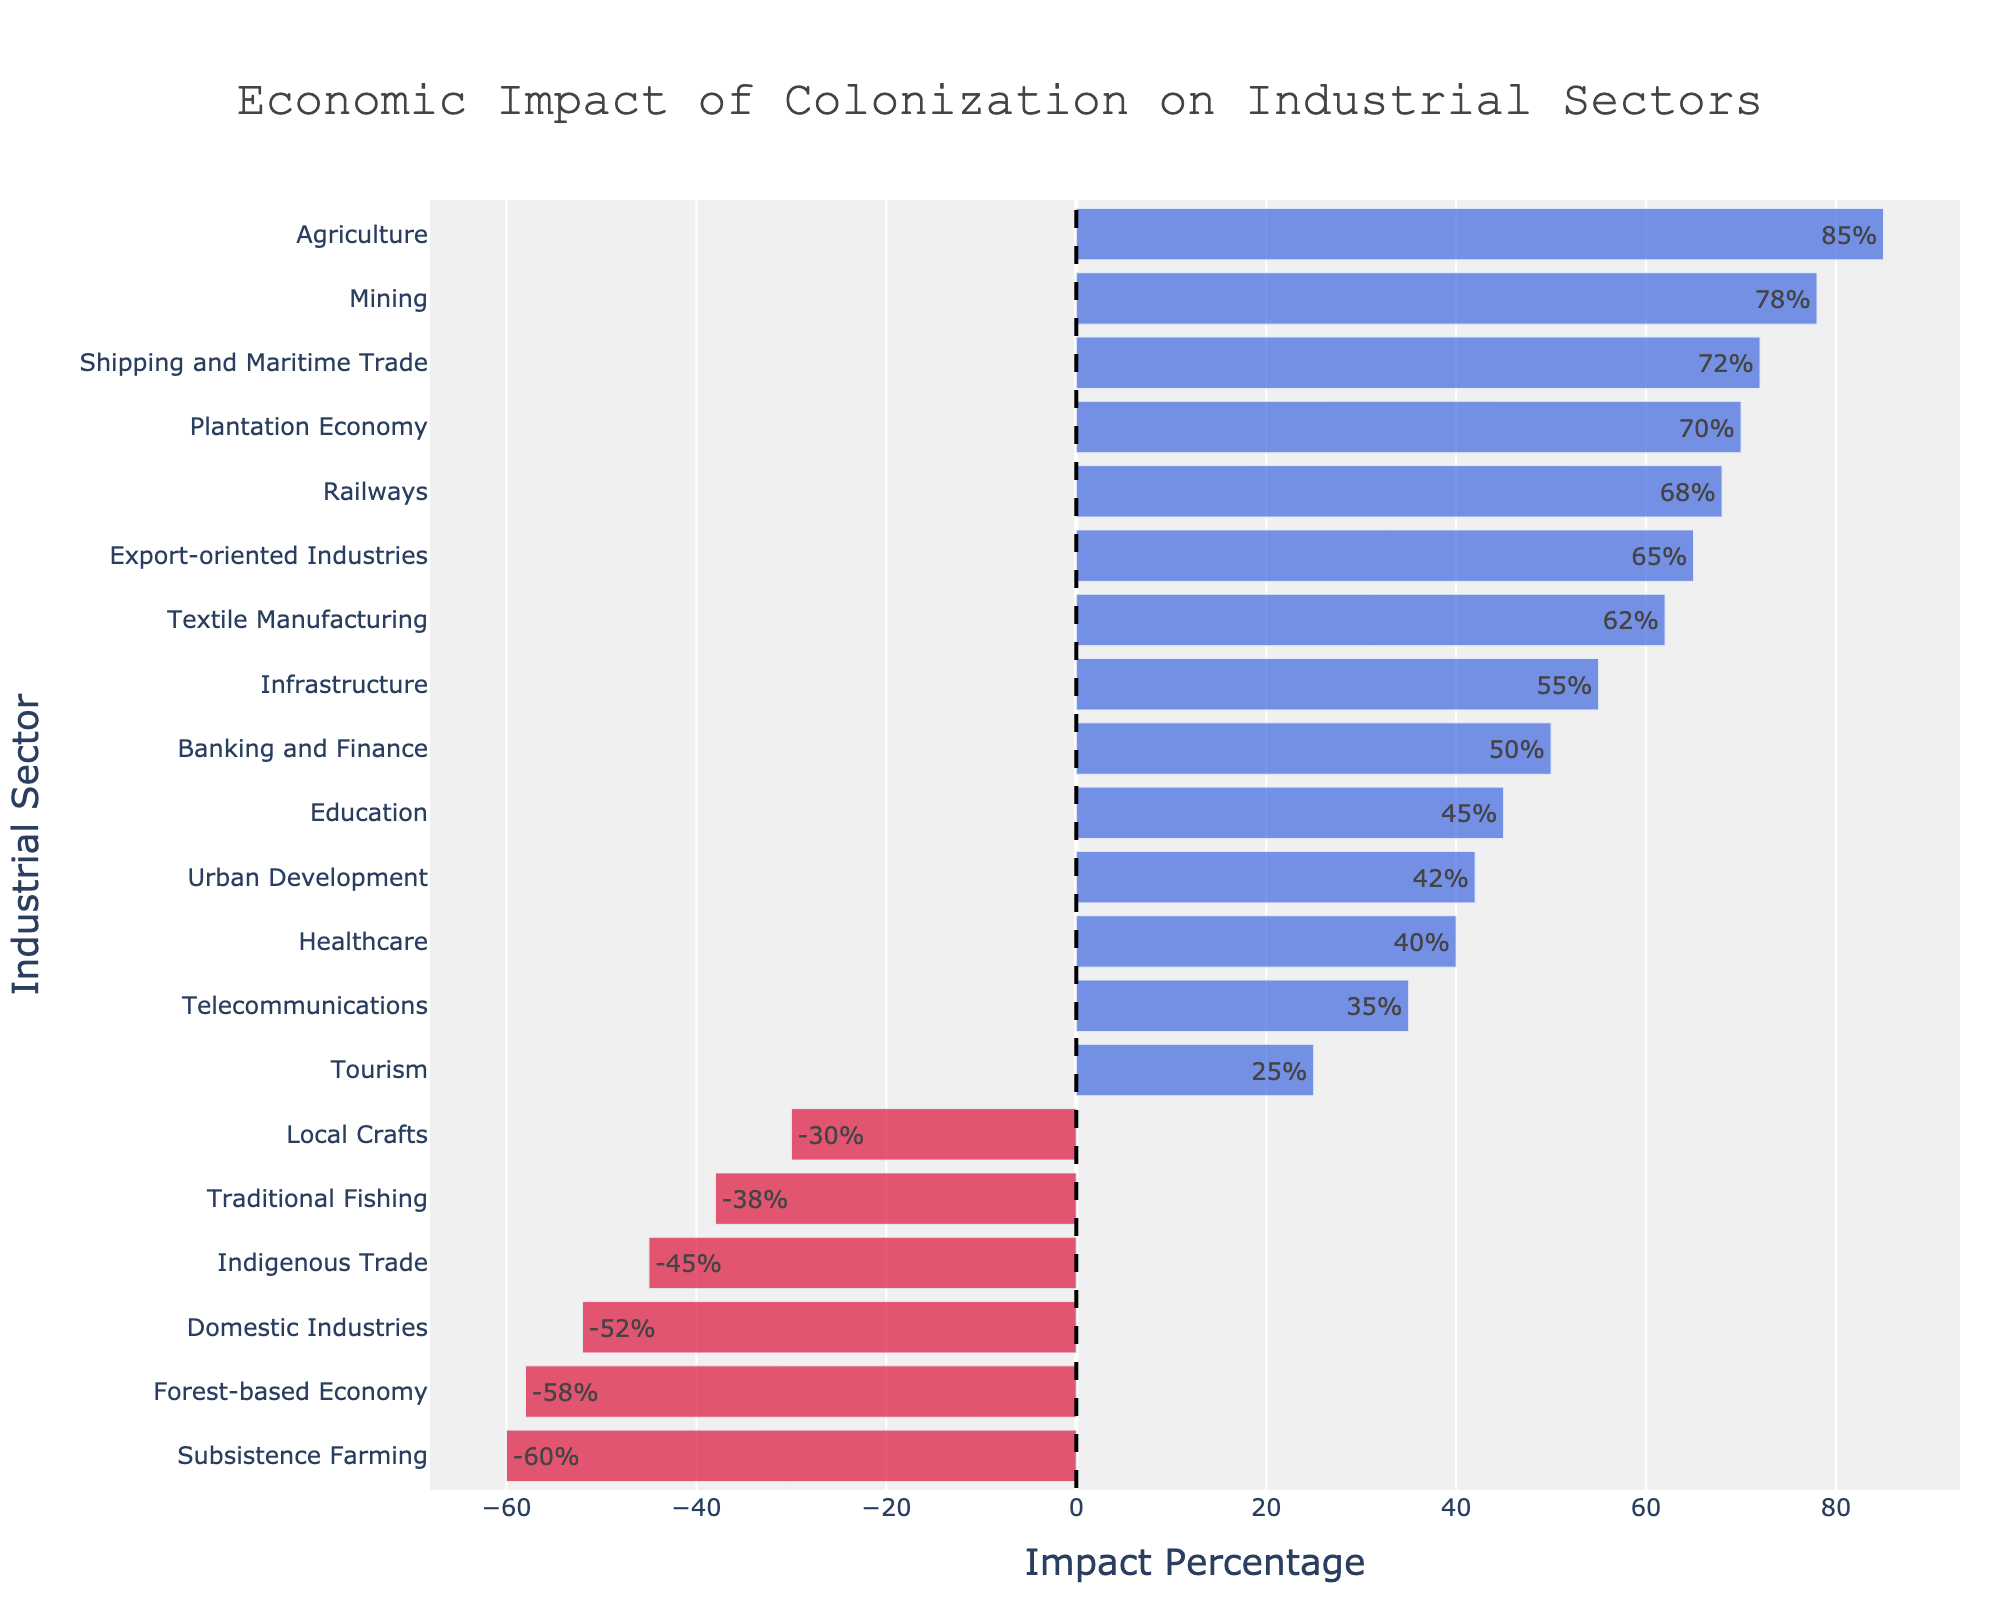What's the sector with the highest positive economic impact of colonization? By observing the heights of the bars representing the positive impacts, it is evident that the Agriculture sector has the highest positive percentage of 85%.
Answer: Agriculture Which sector experienced the most negative economic impact of colonization? By looking at the bar with the longest negative length, Subsistence Farming shows the greatest negative impact with -60%.
Answer: Subsistence Farming How many sectors showed a positive economic impact, and what is their average impact percentage? Counting the bars with positive values, there are 12 sectors. Summing their percentages: 85 + 78 + 62 + 55 + 45 + 40 + 70 + 65 + 50 + 72 + 68 + 35 + 42 + 25 = 692. Dividing by 12 gives the average, which is 692 / 12 ≈ 57.67%.
Answer: 57.67% Which sector has a greater impact, Tourism or Telecommunications? Comparing the lengths of the bars for Tourism and Telecommunications, Tourism has 25% while Telecommunications has 35%. Therefore, Telecommunications has a greater impact.
Answer: Telecommunications What is the difference in impact percentage between Mining and Indigenous Trade? Mining has an impact of 78% while Indigenous Trade has -45%. The difference is 78 - (-45) = 123%.
Answer: 123% What percentage impact does Shipping and Maritime Trade have, and which other sector has a similar impact? Shipping and Maritime Trade has an impact of 72%. A similar value is for Railways, with a 68% impact.
Answer: Railways Which sector has a lower impact, Infrastructure or Urban Development? The percentage impact for Infrastructure is 55%, and for Urban Development, it is 42%. Thus, Urban Development has a lower impact.
Answer: Urban Development What is the range of impact percentages across all sectors? The highest impact is Agriculture (85%) and the lowest is Subsistence Farming (-60%). The range is calculated as 85 - (-60) = 145%.
Answer: 145% How much higher is the impact of the Plantation Economy compared to Domestic Industries? The Plantation Economy has an impact of 70%, while Domestic Industries have -52%. The difference is calculated as 70 - (-52) = 122%.
Answer: 122% How many sectors have a negative economic impact, and what is their average impact percentage? Counting the bars with negative values, there are 6 sectors. Summing their percentages: -30 + (-45) + (-38) + (-60) + (-52) + (-58) = -283. Dividing by 6 gives the average, which is -283 / 6 ≈ -47.17%.
Answer: 47.17% 